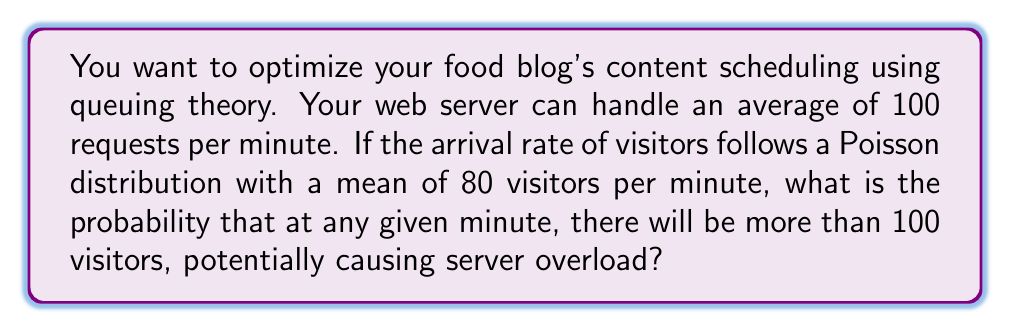Give your solution to this math problem. To solve this problem, we'll use the Poisson distribution and its cumulative distribution function.

1. Define the parameters:
   $\lambda = 80$ (mean arrival rate per minute)
   $k = 100$ (threshold for server overload)

2. We need to find $P(X > 100)$, where $X$ is the number of visitors per minute.

3. This is equivalent to $1 - P(X \leq 100)$

4. The cumulative distribution function of the Poisson distribution is:

   $$P(X \leq k) = e^{-\lambda} \sum_{i=0}^k \frac{\lambda^i}{i!}$$

5. Substituting our values:

   $$P(X \leq 100) = e^{-80} \sum_{i=0}^{100} \frac{80^i}{i!}$$

6. This calculation is complex to do by hand, so we typically use statistical software or programming languages to compute it.

7. Using such tools, we find that $P(X \leq 100) \approx 0.9893$

8. Therefore, $P(X > 100) = 1 - P(X \leq 100) \approx 1 - 0.9893 = 0.0107$

This means there's approximately a 1.07% chance of having more than 100 visitors in any given minute, potentially causing server overload.
Answer: 0.0107 or 1.07% 